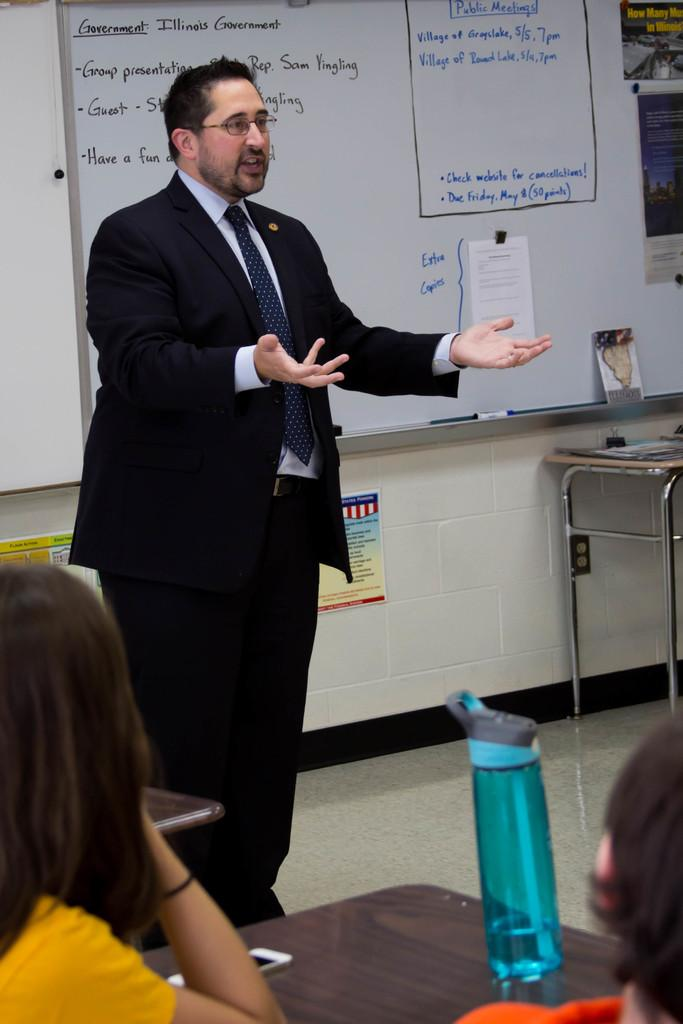<image>
Offer a succinct explanation of the picture presented. a man is speaking to a class in front of a white board that has Illinois government information on it 